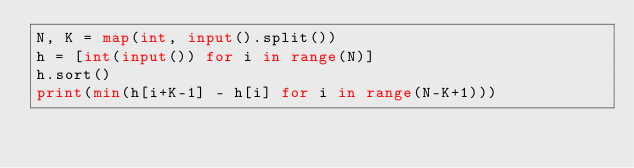Convert code to text. <code><loc_0><loc_0><loc_500><loc_500><_Python_>N, K = map(int, input().split())
h = [int(input()) for i in range(N)]
h.sort()
print(min(h[i+K-1] - h[i] for i in range(N-K+1)))
</code> 